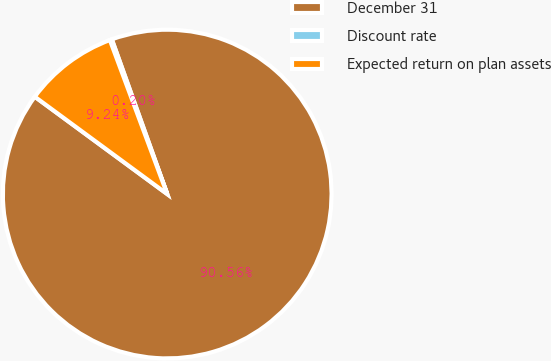Convert chart. <chart><loc_0><loc_0><loc_500><loc_500><pie_chart><fcel>December 31<fcel>Discount rate<fcel>Expected return on plan assets<nl><fcel>90.56%<fcel>0.2%<fcel>9.24%<nl></chart> 